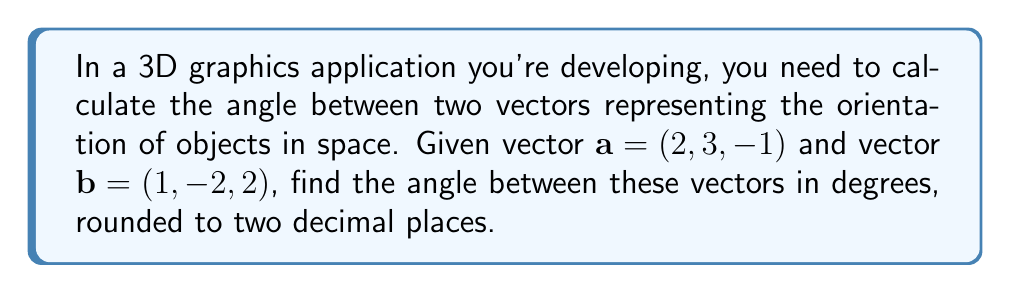Show me your answer to this math problem. To find the angle between two vectors in 3D space, we can use the dot product formula:

$$\cos \theta = \frac{\mathbf{a} \cdot \mathbf{b}}{|\mathbf{a}| |\mathbf{b}|}$$

Where $\theta$ is the angle between the vectors, $\mathbf{a} \cdot \mathbf{b}$ is the dot product, and $|\mathbf{a}|$ and $|\mathbf{b}|$ are the magnitudes of vectors $\mathbf{a}$ and $\mathbf{b}$ respectively.

Step 1: Calculate the dot product $\mathbf{a} \cdot \mathbf{b}$
$$\mathbf{a} \cdot \mathbf{b} = (2)(1) + (3)(-2) + (-1)(2) = 2 - 6 - 2 = -6$$

Step 2: Calculate the magnitudes of $\mathbf{a}$ and $\mathbf{b}$
$$|\mathbf{a}| = \sqrt{2^2 + 3^2 + (-1)^2} = \sqrt{4 + 9 + 1} = \sqrt{14}$$
$$|\mathbf{b}| = \sqrt{1^2 + (-2)^2 + 2^2} = \sqrt{1 + 4 + 4} = 3$$

Step 3: Substitute into the dot product formula
$$\cos \theta = \frac{-6}{\sqrt{14} \cdot 3}$$

Step 4: Solve for $\theta$ using the inverse cosine (arccos) function
$$\theta = \arccos\left(\frac{-6}{\sqrt{14} \cdot 3}\right)$$

Step 5: Convert radians to degrees and round to two decimal places
$$\theta \approx 132.32^\circ$$
Answer: 132.32° 